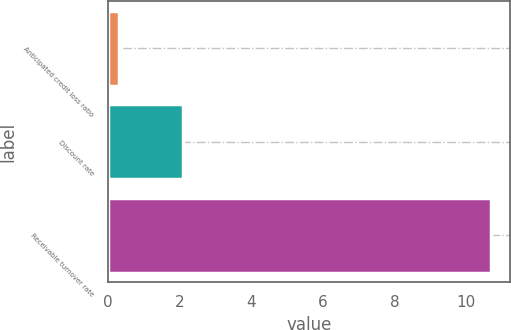<chart> <loc_0><loc_0><loc_500><loc_500><bar_chart><fcel>Anticipated credit loss ratio<fcel>Discount rate<fcel>Receivable turnover rate<nl><fcel>0.3<fcel>2.1<fcel>10.7<nl></chart> 